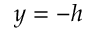Convert formula to latex. <formula><loc_0><loc_0><loc_500><loc_500>y = - h</formula> 